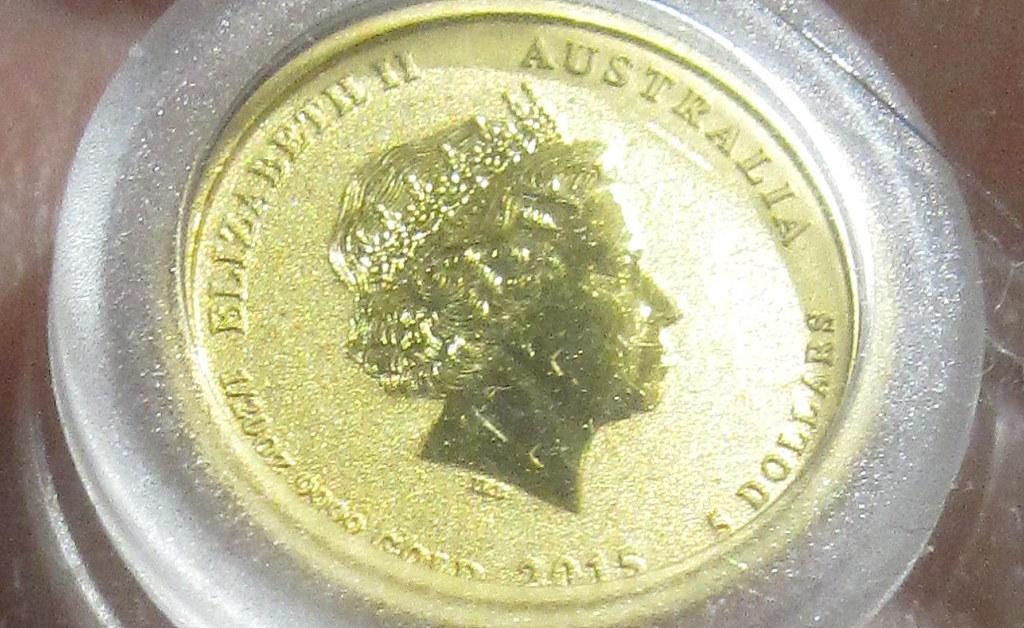Which queen is on the coin?
Give a very brief answer. Elizabeth ii. Is this australian coin worth five dollars?
Your answer should be compact. Yes. 